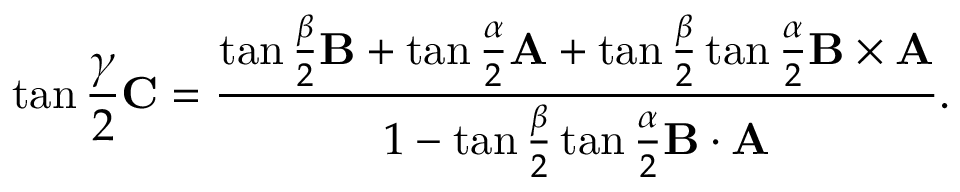Convert formula to latex. <formula><loc_0><loc_0><loc_500><loc_500>\tan { \frac { \gamma } { 2 } } C = { \frac { \tan { \frac { \beta } { 2 } } B + \tan { \frac { \alpha } { 2 } } A + \tan { \frac { \beta } { 2 } } \tan { \frac { \alpha } { 2 } } B \times A } { 1 - \tan { \frac { \beta } { 2 } } \tan { \frac { \alpha } { 2 } } B \cdot A } } .</formula> 